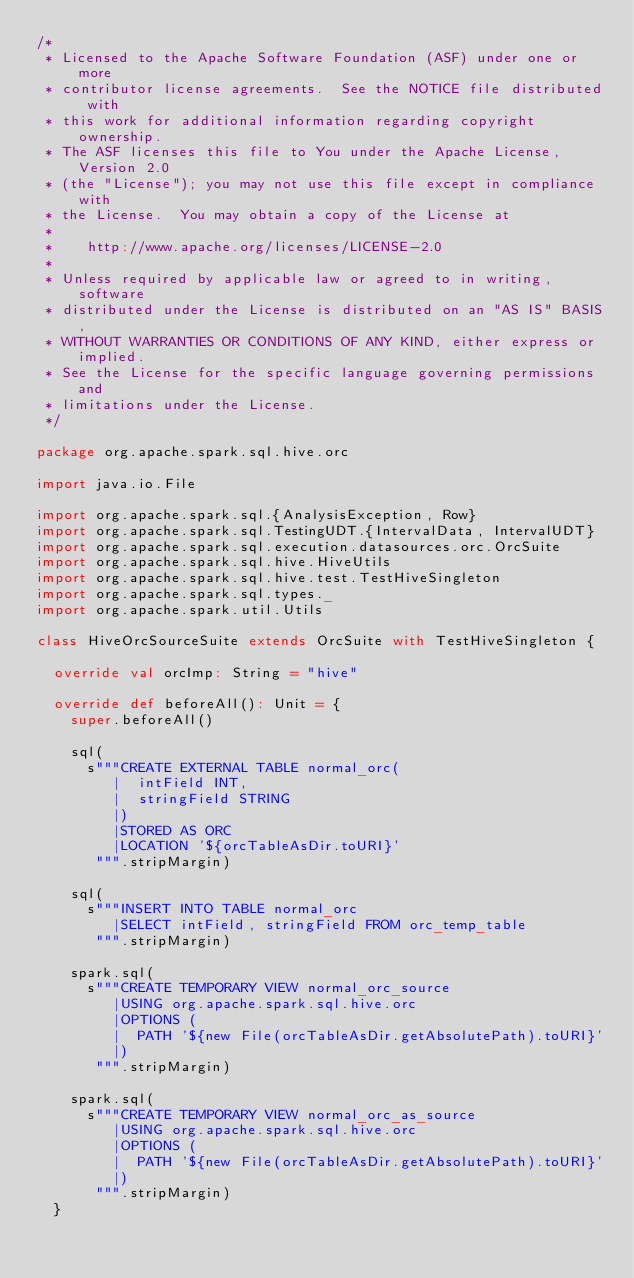<code> <loc_0><loc_0><loc_500><loc_500><_Scala_>/*
 * Licensed to the Apache Software Foundation (ASF) under one or more
 * contributor license agreements.  See the NOTICE file distributed with
 * this work for additional information regarding copyright ownership.
 * The ASF licenses this file to You under the Apache License, Version 2.0
 * (the "License"); you may not use this file except in compliance with
 * the License.  You may obtain a copy of the License at
 *
 *    http://www.apache.org/licenses/LICENSE-2.0
 *
 * Unless required by applicable law or agreed to in writing, software
 * distributed under the License is distributed on an "AS IS" BASIS,
 * WITHOUT WARRANTIES OR CONDITIONS OF ANY KIND, either express or implied.
 * See the License for the specific language governing permissions and
 * limitations under the License.
 */

package org.apache.spark.sql.hive.orc

import java.io.File

import org.apache.spark.sql.{AnalysisException, Row}
import org.apache.spark.sql.TestingUDT.{IntervalData, IntervalUDT}
import org.apache.spark.sql.execution.datasources.orc.OrcSuite
import org.apache.spark.sql.hive.HiveUtils
import org.apache.spark.sql.hive.test.TestHiveSingleton
import org.apache.spark.sql.types._
import org.apache.spark.util.Utils

class HiveOrcSourceSuite extends OrcSuite with TestHiveSingleton {

  override val orcImp: String = "hive"

  override def beforeAll(): Unit = {
    super.beforeAll()

    sql(
      s"""CREATE EXTERNAL TABLE normal_orc(
         |  intField INT,
         |  stringField STRING
         |)
         |STORED AS ORC
         |LOCATION '${orcTableAsDir.toURI}'
       """.stripMargin)

    sql(
      s"""INSERT INTO TABLE normal_orc
         |SELECT intField, stringField FROM orc_temp_table
       """.stripMargin)

    spark.sql(
      s"""CREATE TEMPORARY VIEW normal_orc_source
         |USING org.apache.spark.sql.hive.orc
         |OPTIONS (
         |  PATH '${new File(orcTableAsDir.getAbsolutePath).toURI}'
         |)
       """.stripMargin)

    spark.sql(
      s"""CREATE TEMPORARY VIEW normal_orc_as_source
         |USING org.apache.spark.sql.hive.orc
         |OPTIONS (
         |  PATH '${new File(orcTableAsDir.getAbsolutePath).toURI}'
         |)
       """.stripMargin)
  }
</code> 